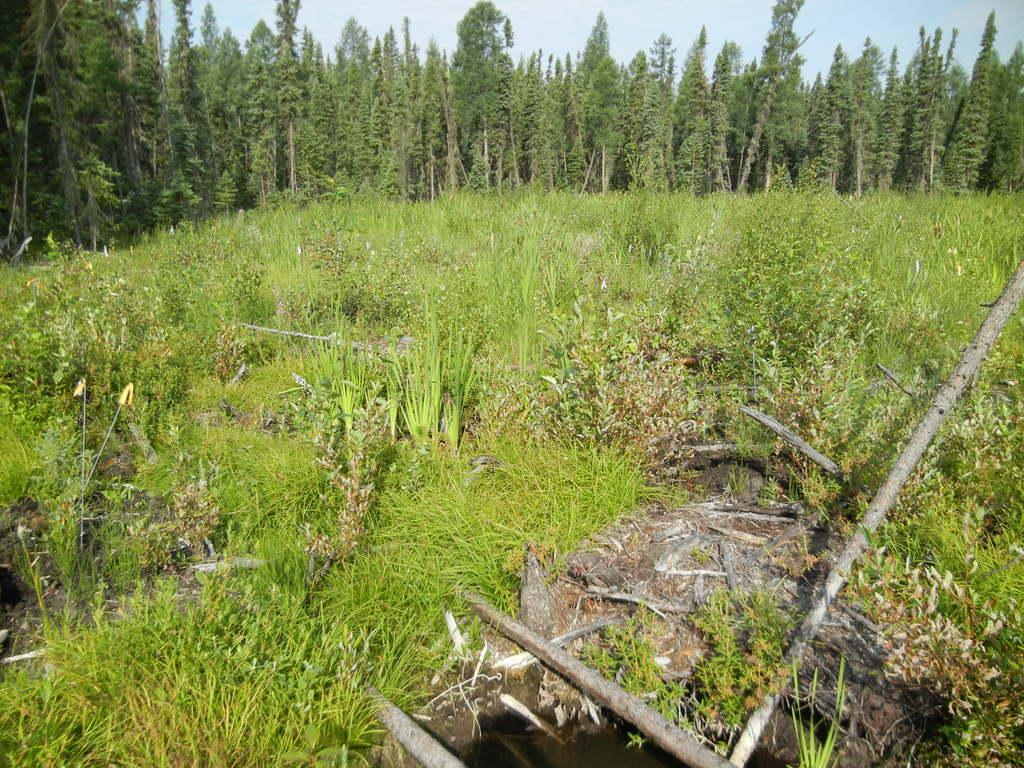What type of vegetation can be seen in the image? There are trees in the image. What is the color of the grass in the image? The grass in the image is green. What objects made of wood can be seen in the image? There are sticks in the image. What color is the sky in the image? The sky is blue in color. How many robins are sitting on the bike in the image? There are no robins or bikes present in the image. 